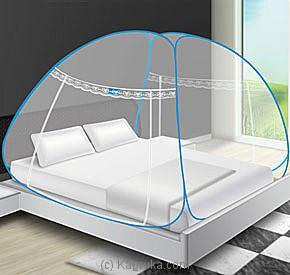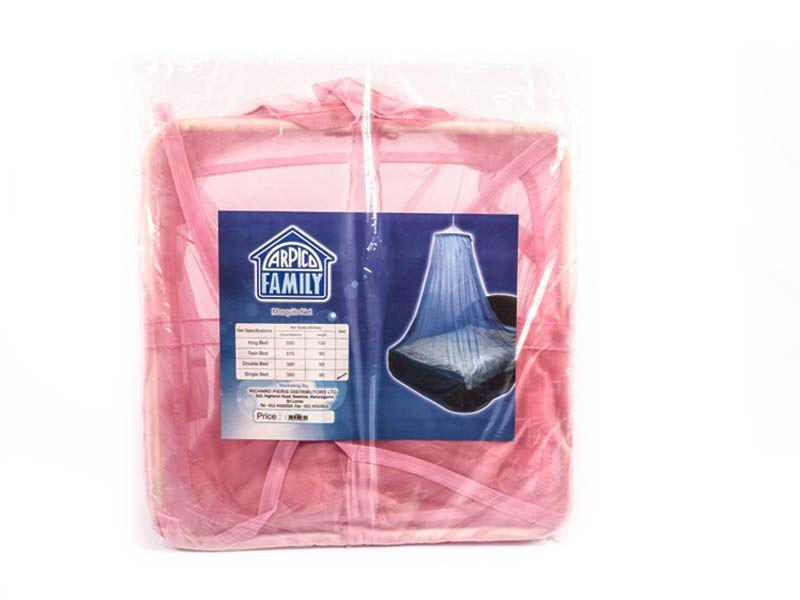The first image is the image on the left, the second image is the image on the right. Analyze the images presented: Is the assertion "There are two canopies tents." valid? Answer yes or no. No. The first image is the image on the left, the second image is the image on the right. Assess this claim about the two images: "In the image to the right, the bed-tent is white.". Correct or not? Answer yes or no. No. 